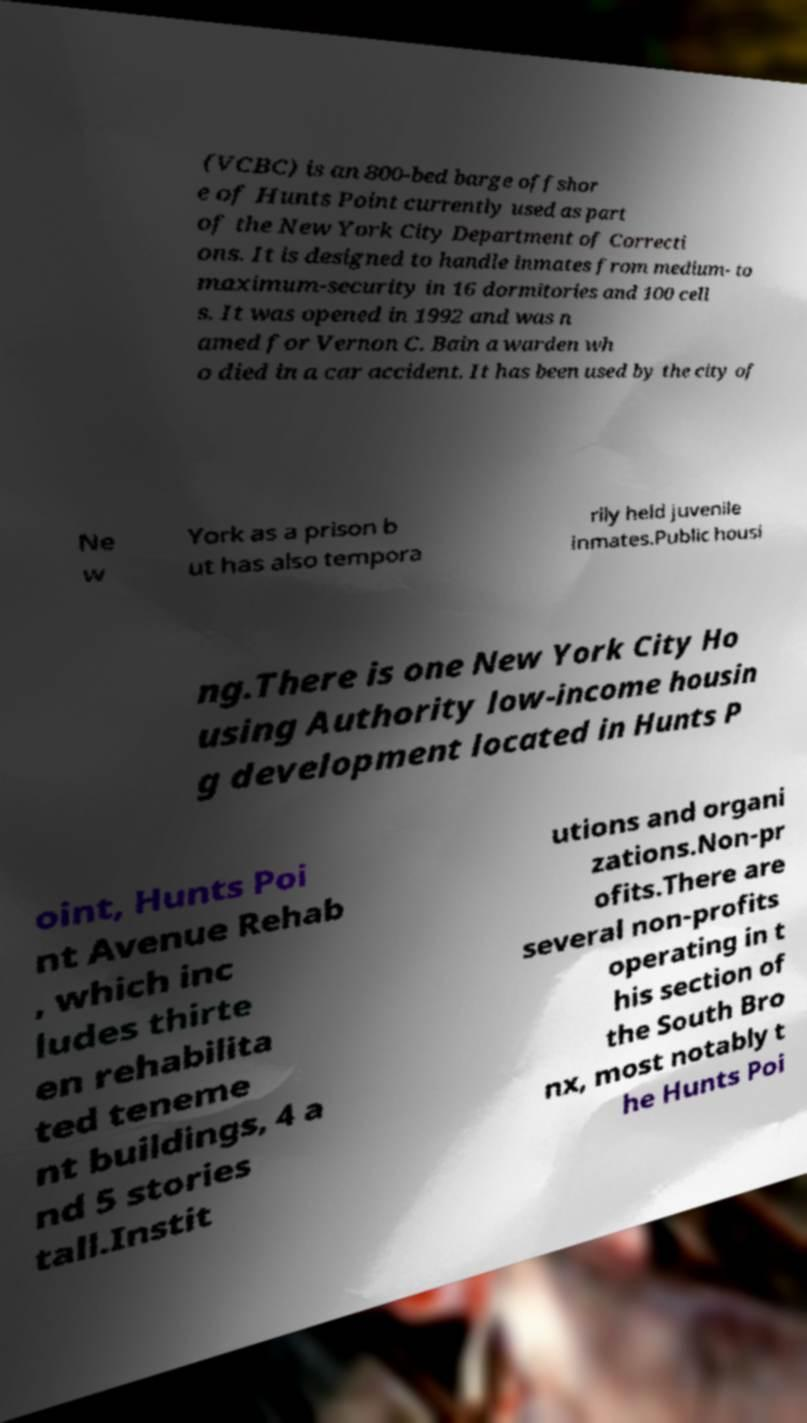Can you read and provide the text displayed in the image?This photo seems to have some interesting text. Can you extract and type it out for me? (VCBC) is an 800-bed barge offshor e of Hunts Point currently used as part of the New York City Department of Correcti ons. It is designed to handle inmates from medium- to maximum-security in 16 dormitories and 100 cell s. It was opened in 1992 and was n amed for Vernon C. Bain a warden wh o died in a car accident. It has been used by the city of Ne w York as a prison b ut has also tempora rily held juvenile inmates.Public housi ng.There is one New York City Ho using Authority low-income housin g development located in Hunts P oint, Hunts Poi nt Avenue Rehab , which inc ludes thirte en rehabilita ted teneme nt buildings, 4 a nd 5 stories tall.Instit utions and organi zations.Non-pr ofits.There are several non-profits operating in t his section of the South Bro nx, most notably t he Hunts Poi 